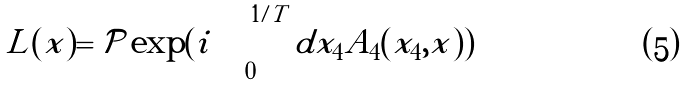<formula> <loc_0><loc_0><loc_500><loc_500>L ( x ) = { \mathcal { P } } \exp ( i \int _ { 0 } ^ { 1 / T } d x _ { 4 } A _ { 4 } ( x _ { 4 } , x ) )</formula> 